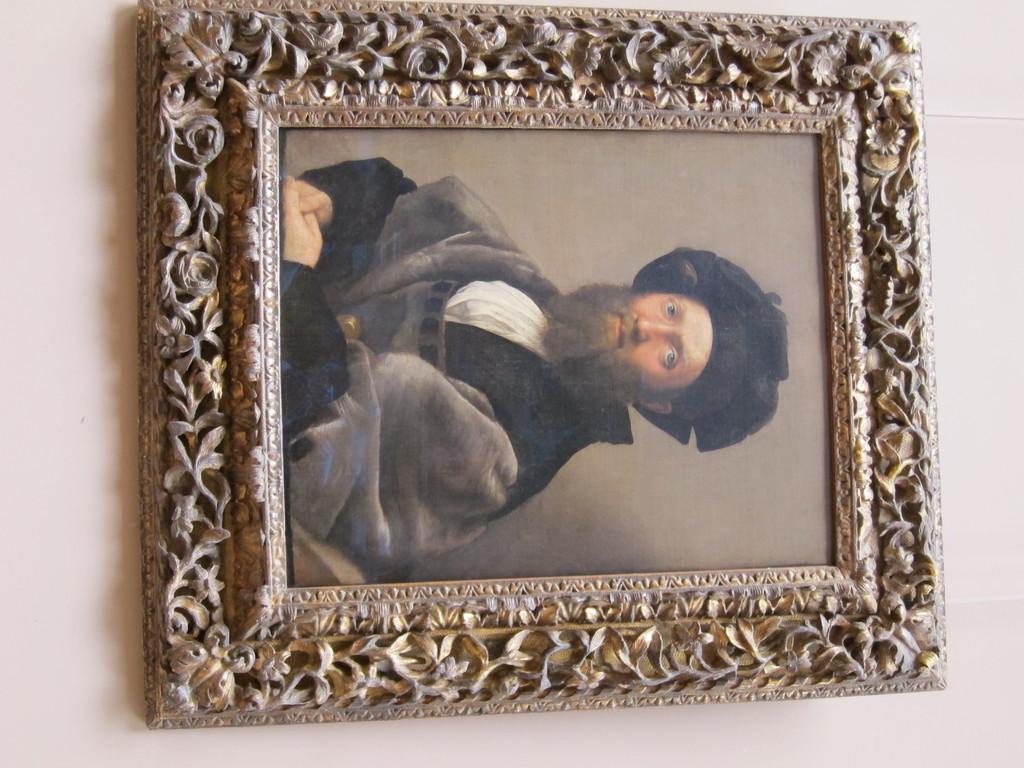Describe this image in one or two sentences. In this image I can see the photo frame and in it I can see a photograph of a person wearing black and white colored dress. I can see the light pink colored background. 